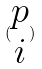<formula> <loc_0><loc_0><loc_500><loc_500>( \begin{matrix} p \\ i \end{matrix} )</formula> 